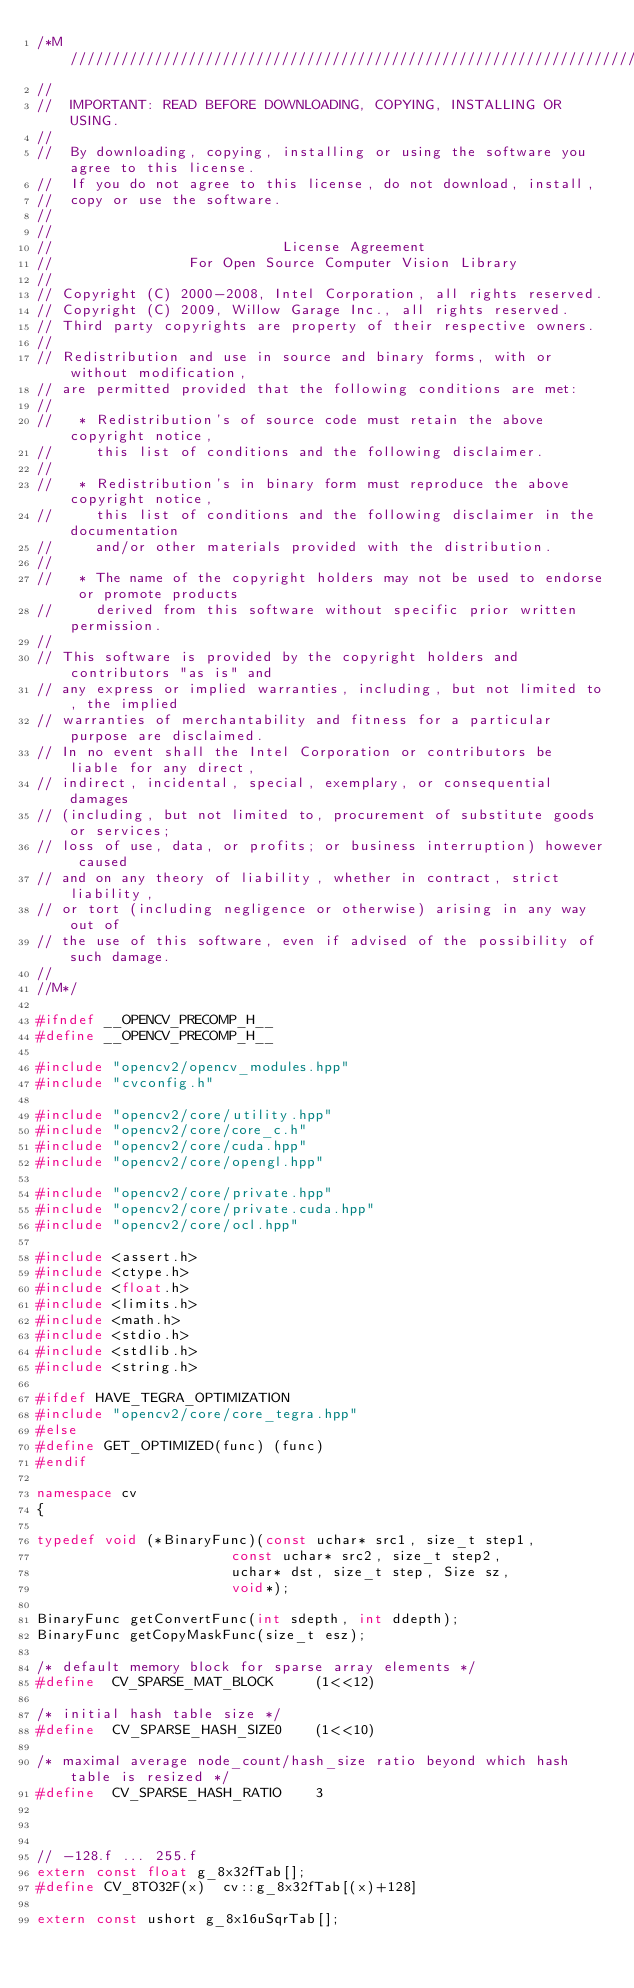Convert code to text. <code><loc_0><loc_0><loc_500><loc_500><_C++_>/*M///////////////////////////////////////////////////////////////////////////////////////
//
//  IMPORTANT: READ BEFORE DOWNLOADING, COPYING, INSTALLING OR USING.
//
//  By downloading, copying, installing or using the software you agree to this license.
//  If you do not agree to this license, do not download, install,
//  copy or use the software.
//
//
//                           License Agreement
//                For Open Source Computer Vision Library
//
// Copyright (C) 2000-2008, Intel Corporation, all rights reserved.
// Copyright (C) 2009, Willow Garage Inc., all rights reserved.
// Third party copyrights are property of their respective owners.
//
// Redistribution and use in source and binary forms, with or without modification,
// are permitted provided that the following conditions are met:
//
//   * Redistribution's of source code must retain the above copyright notice,
//     this list of conditions and the following disclaimer.
//
//   * Redistribution's in binary form must reproduce the above copyright notice,
//     this list of conditions and the following disclaimer in the documentation
//     and/or other materials provided with the distribution.
//
//   * The name of the copyright holders may not be used to endorse or promote products
//     derived from this software without specific prior written permission.
//
// This software is provided by the copyright holders and contributors "as is" and
// any express or implied warranties, including, but not limited to, the implied
// warranties of merchantability and fitness for a particular purpose are disclaimed.
// In no event shall the Intel Corporation or contributors be liable for any direct,
// indirect, incidental, special, exemplary, or consequential damages
// (including, but not limited to, procurement of substitute goods or services;
// loss of use, data, or profits; or business interruption) however caused
// and on any theory of liability, whether in contract, strict liability,
// or tort (including negligence or otherwise) arising in any way out of
// the use of this software, even if advised of the possibility of such damage.
//
//M*/

#ifndef __OPENCV_PRECOMP_H__
#define __OPENCV_PRECOMP_H__

#include "opencv2/opencv_modules.hpp"
#include "cvconfig.h"

#include "opencv2/core/utility.hpp"
#include "opencv2/core/core_c.h"
#include "opencv2/core/cuda.hpp"
#include "opencv2/core/opengl.hpp"

#include "opencv2/core/private.hpp"
#include "opencv2/core/private.cuda.hpp"
#include "opencv2/core/ocl.hpp"

#include <assert.h>
#include <ctype.h>
#include <float.h>
#include <limits.h>
#include <math.h>
#include <stdio.h>
#include <stdlib.h>
#include <string.h>

#ifdef HAVE_TEGRA_OPTIMIZATION
#include "opencv2/core/core_tegra.hpp"
#else
#define GET_OPTIMIZED(func) (func)
#endif

namespace cv
{

typedef void (*BinaryFunc)(const uchar* src1, size_t step1,
                       const uchar* src2, size_t step2,
                       uchar* dst, size_t step, Size sz,
                       void*);

BinaryFunc getConvertFunc(int sdepth, int ddepth);
BinaryFunc getCopyMaskFunc(size_t esz);

/* default memory block for sparse array elements */
#define  CV_SPARSE_MAT_BLOCK     (1<<12)

/* initial hash table size */
#define  CV_SPARSE_HASH_SIZE0    (1<<10)

/* maximal average node_count/hash_size ratio beyond which hash table is resized */
#define  CV_SPARSE_HASH_RATIO    3



// -128.f ... 255.f
extern const float g_8x32fTab[];
#define CV_8TO32F(x)  cv::g_8x32fTab[(x)+128]

extern const ushort g_8x16uSqrTab[];</code> 